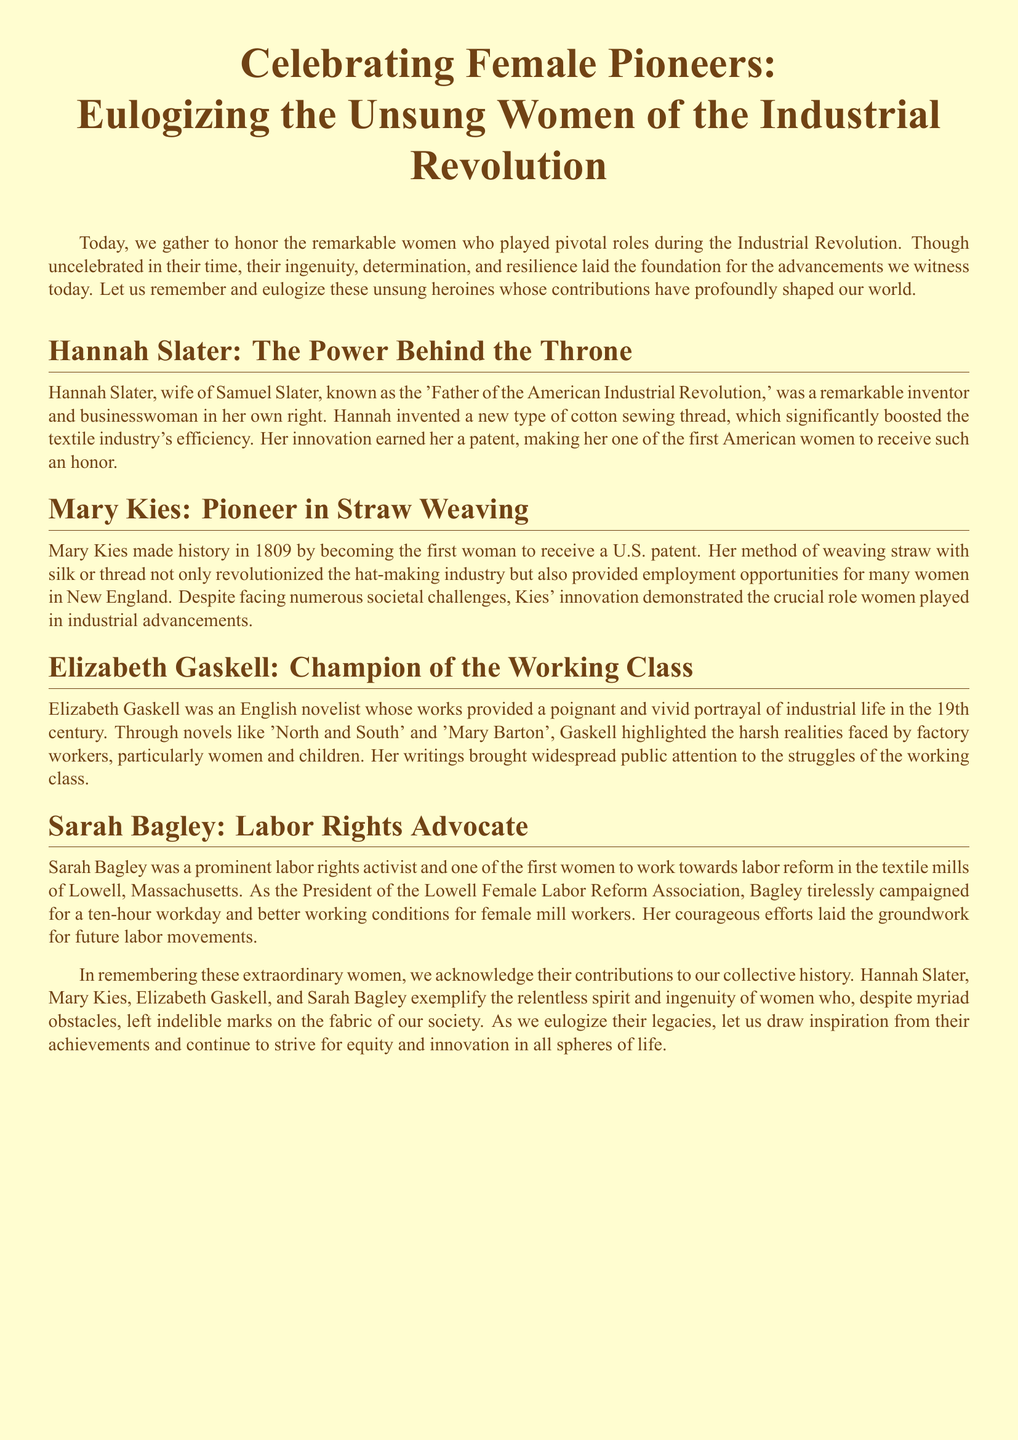What significant invention is attributed to Hannah Slater? Hannah Slater invented a new type of cotton sewing thread, significantly boosting the textile industry's efficiency.
Answer: cotton sewing thread Who was the first woman to receive a U.S. patent? Mary Kies made history in 1809 by becoming the first woman to receive a U.S. patent for her straw weaving method.
Answer: Mary Kies What was Sarah Bagley's role in the labor movement? Sarah Bagley was the President of the Lowell Female Labor Reform Association, advocating for labor rights and better working conditions.
Answer: President Which literary works did Elizabeth Gaskell author? Elizabeth Gaskell is known for novels like 'North and South' and 'Mary Barton' that portray industrial life and working-class struggles.
Answer: 'North and South' and 'Mary Barton' What impact did Mary Kies' invention have on employment? Her method of weaving straw with silk provided employment opportunities for many women in New England.
Answer: employment opportunities 